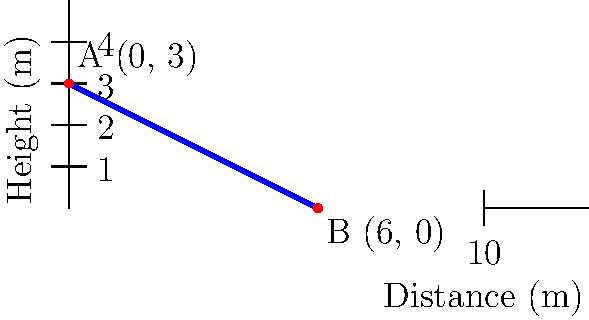During a crucial match against Merrimack Warriors, you observe their star player performing a powerful spike. The trajectory of the volleyball can be represented by the line shown in the graph. If point A represents the initial position of the ball at the moment of contact, and point B represents its position when it crosses the net, what is the slope of this line? Round your answer to two decimal places. To find the slope of the line representing the volleyball's trajectory, we can use the slope formula:

$$ m = \frac{y_2 - y_1}{x_2 - x_1} $$

Where $(x_1, y_1)$ is the coordinates of point A, and $(x_2, y_2)$ is the coordinates of point B.

From the graph, we can see that:
Point A: $(0, 3)$
Point B: $(6, 0)$

Let's plug these values into the slope formula:

$$ m = \frac{0 - 3}{6 - 0} = \frac{-3}{6} $$

Simplifying:

$$ m = -\frac{1}{2} = -0.5 $$

Therefore, the slope of the line is -0.5.

Rounded to two decimal places, the answer remains -0.50.
Answer: -0.50 